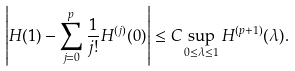Convert formula to latex. <formula><loc_0><loc_0><loc_500><loc_500>\left | H ( 1 ) - \sum _ { j = 0 } ^ { p } \frac { 1 } { j ! } H ^ { ( j ) } ( 0 ) \right | \leq C \sup _ { 0 \leq \lambda \leq 1 } H ^ { ( p + 1 ) } ( \lambda ) .</formula> 